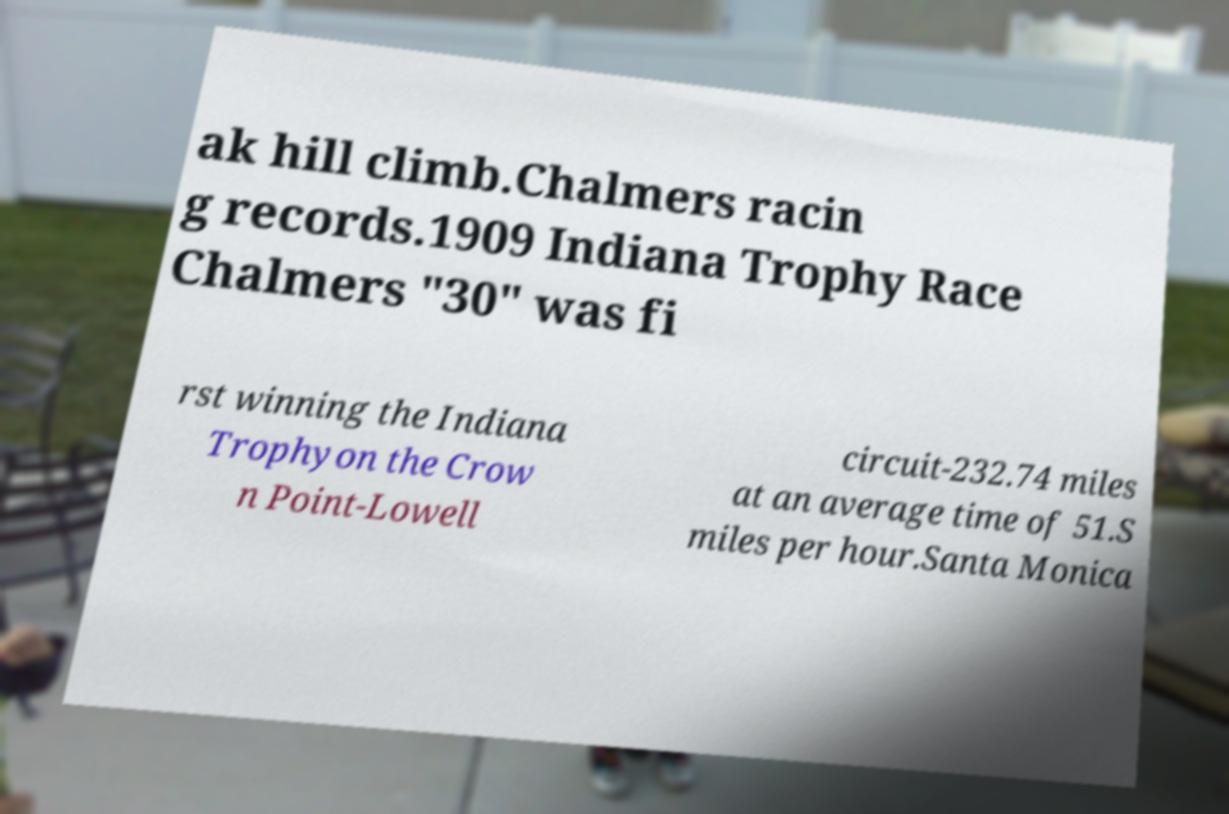For documentation purposes, I need the text within this image transcribed. Could you provide that? ak hill climb.Chalmers racin g records.1909 Indiana Trophy Race Chalmers "30" was fi rst winning the Indiana Trophyon the Crow n Point-Lowell circuit-232.74 miles at an average time of 51.S miles per hour.Santa Monica 